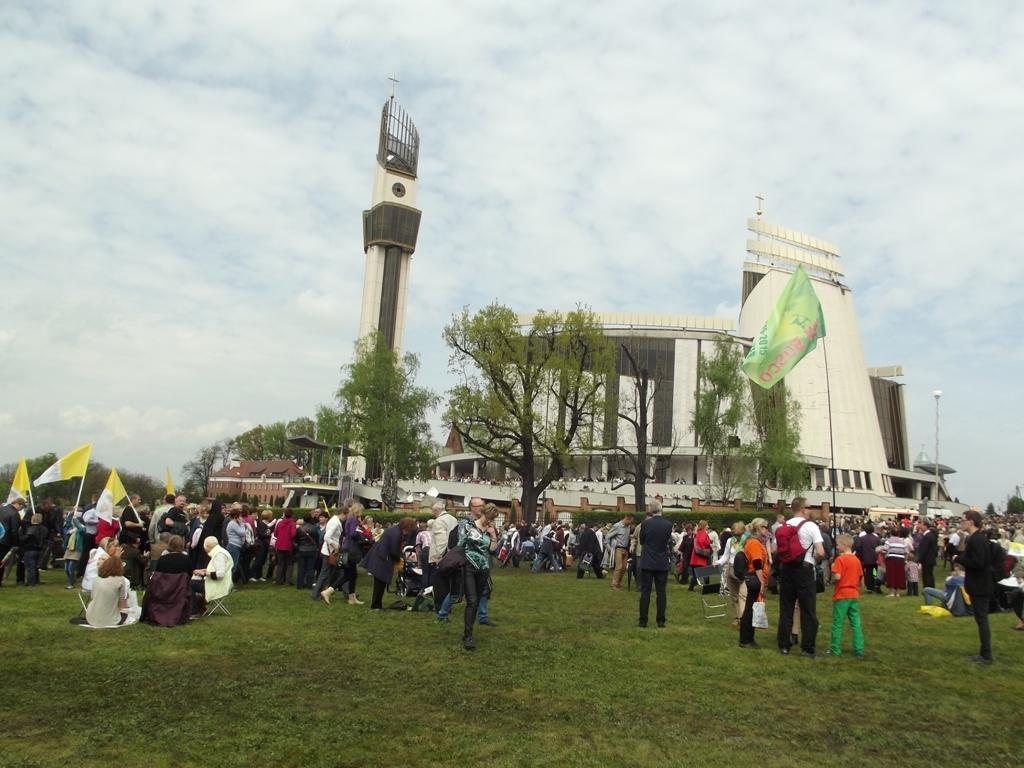How would you summarize this image in a sentence or two? In the background of the image there is a building. There are trees. At the bottom of the image there is grass. There are people walking on the grass. At the top of the image there is sky and clouds. 